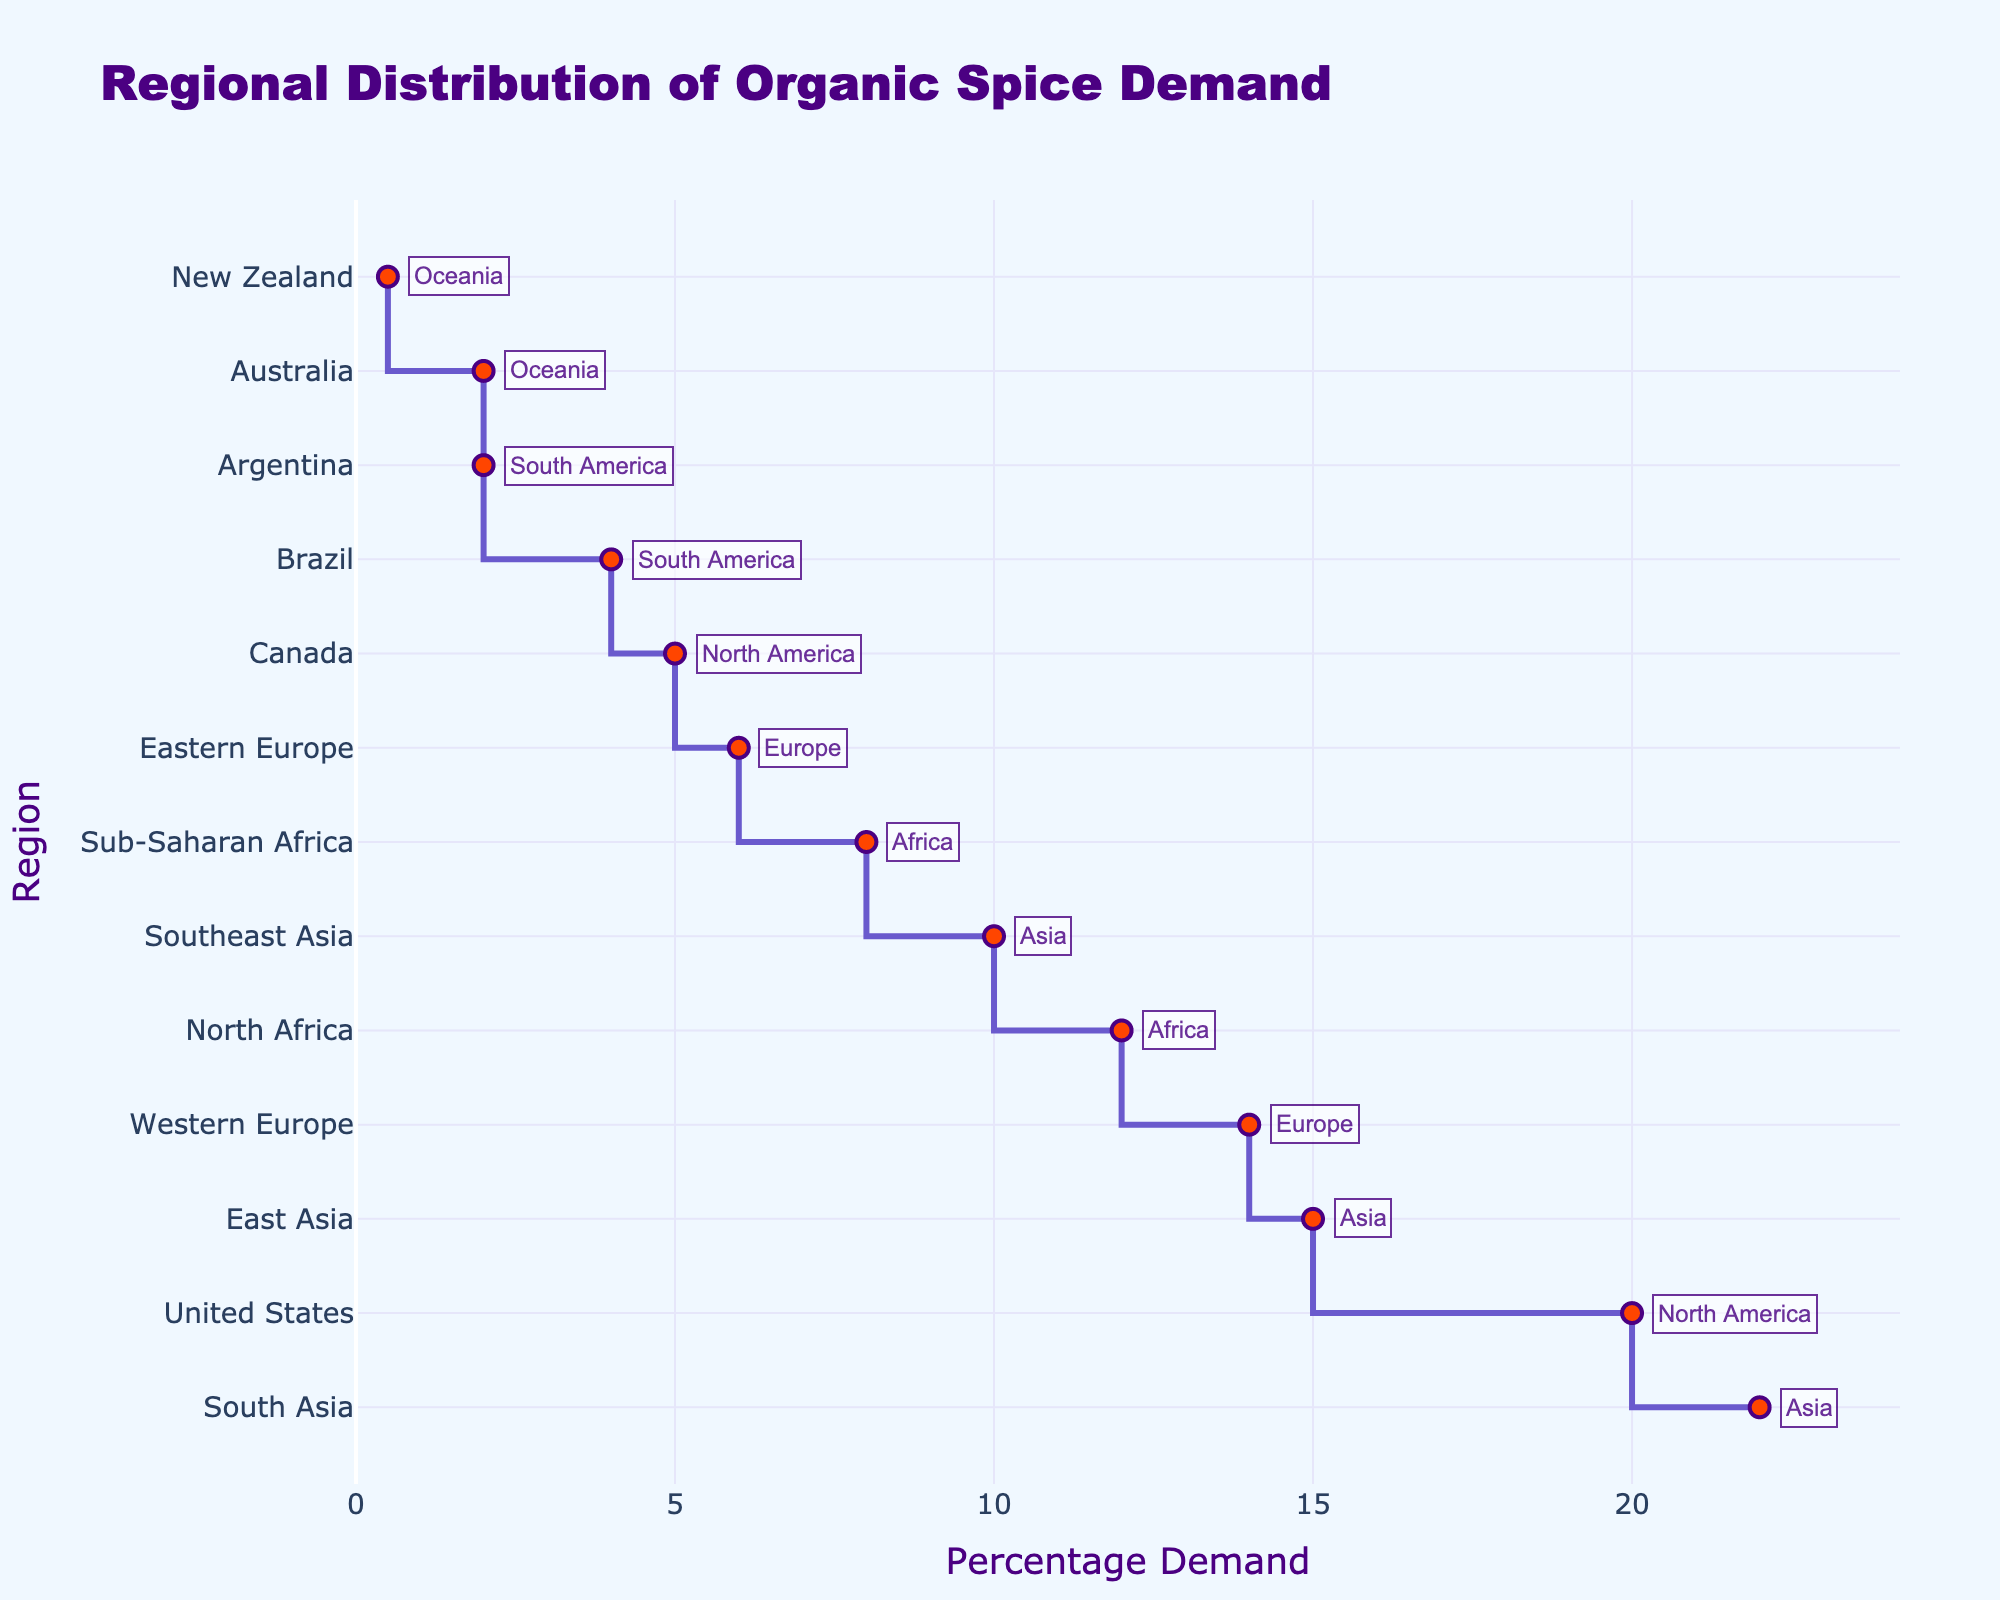what is the title of the plot? Refer to the top of the figure where the title is displayed in a large font.
Answer: Regional Distribution of Organic Spice Demand Which region has the highest percentage demand? Look for the region at the top of the stair plot, which represents the highest value along the x-axis.
Answer: South Asia What is the percentage demand for the United States? Find "United States" on the y-axis and follow the stair step to the percentage on the x-axis.
Answer: 20% How does the percentage demand in Western Europe compare to that in Eastern Europe? Locate both "Western Europe" and "Eastern Europe" on the y-axis. Compare their percentage values on the x-axis.
Answer: Western Europe (14%) is higher than Eastern Europe (6%) Which regions in Asia have a demand percentage greater than 10%? Identify the regions in Asia and check their percentage demands.
Answer: East Asia, South Asia What is the combined percentage demand for North Africa and Sub-Saharan Africa? Find the percentage demands for "North Africa" (12%) and "Sub-Saharan Africa" (8%) on the x-axis, and add them together.
Answer: 20% Which continent has the smallest overall percentage demand based on its regions? Look for the continent with the lowest percentage demands among its regions.
Answer: Oceania What is the median percentage demand value for all regions? Arrange all percentage demand values in numerical order and find the middle value. For 13 regions, the median is the 7th value.
Answer: 8% How many regions have a percentage demand under 5%? Count the regions with demand values below 5% on the x-axis.
Answer: 4 Which region in North America has a higher percentage demand, and what is that value? Compare "United States" and "Canada" on the y-axis, and find their percentage demands on the x-axis.
Answer: United States (20%) 